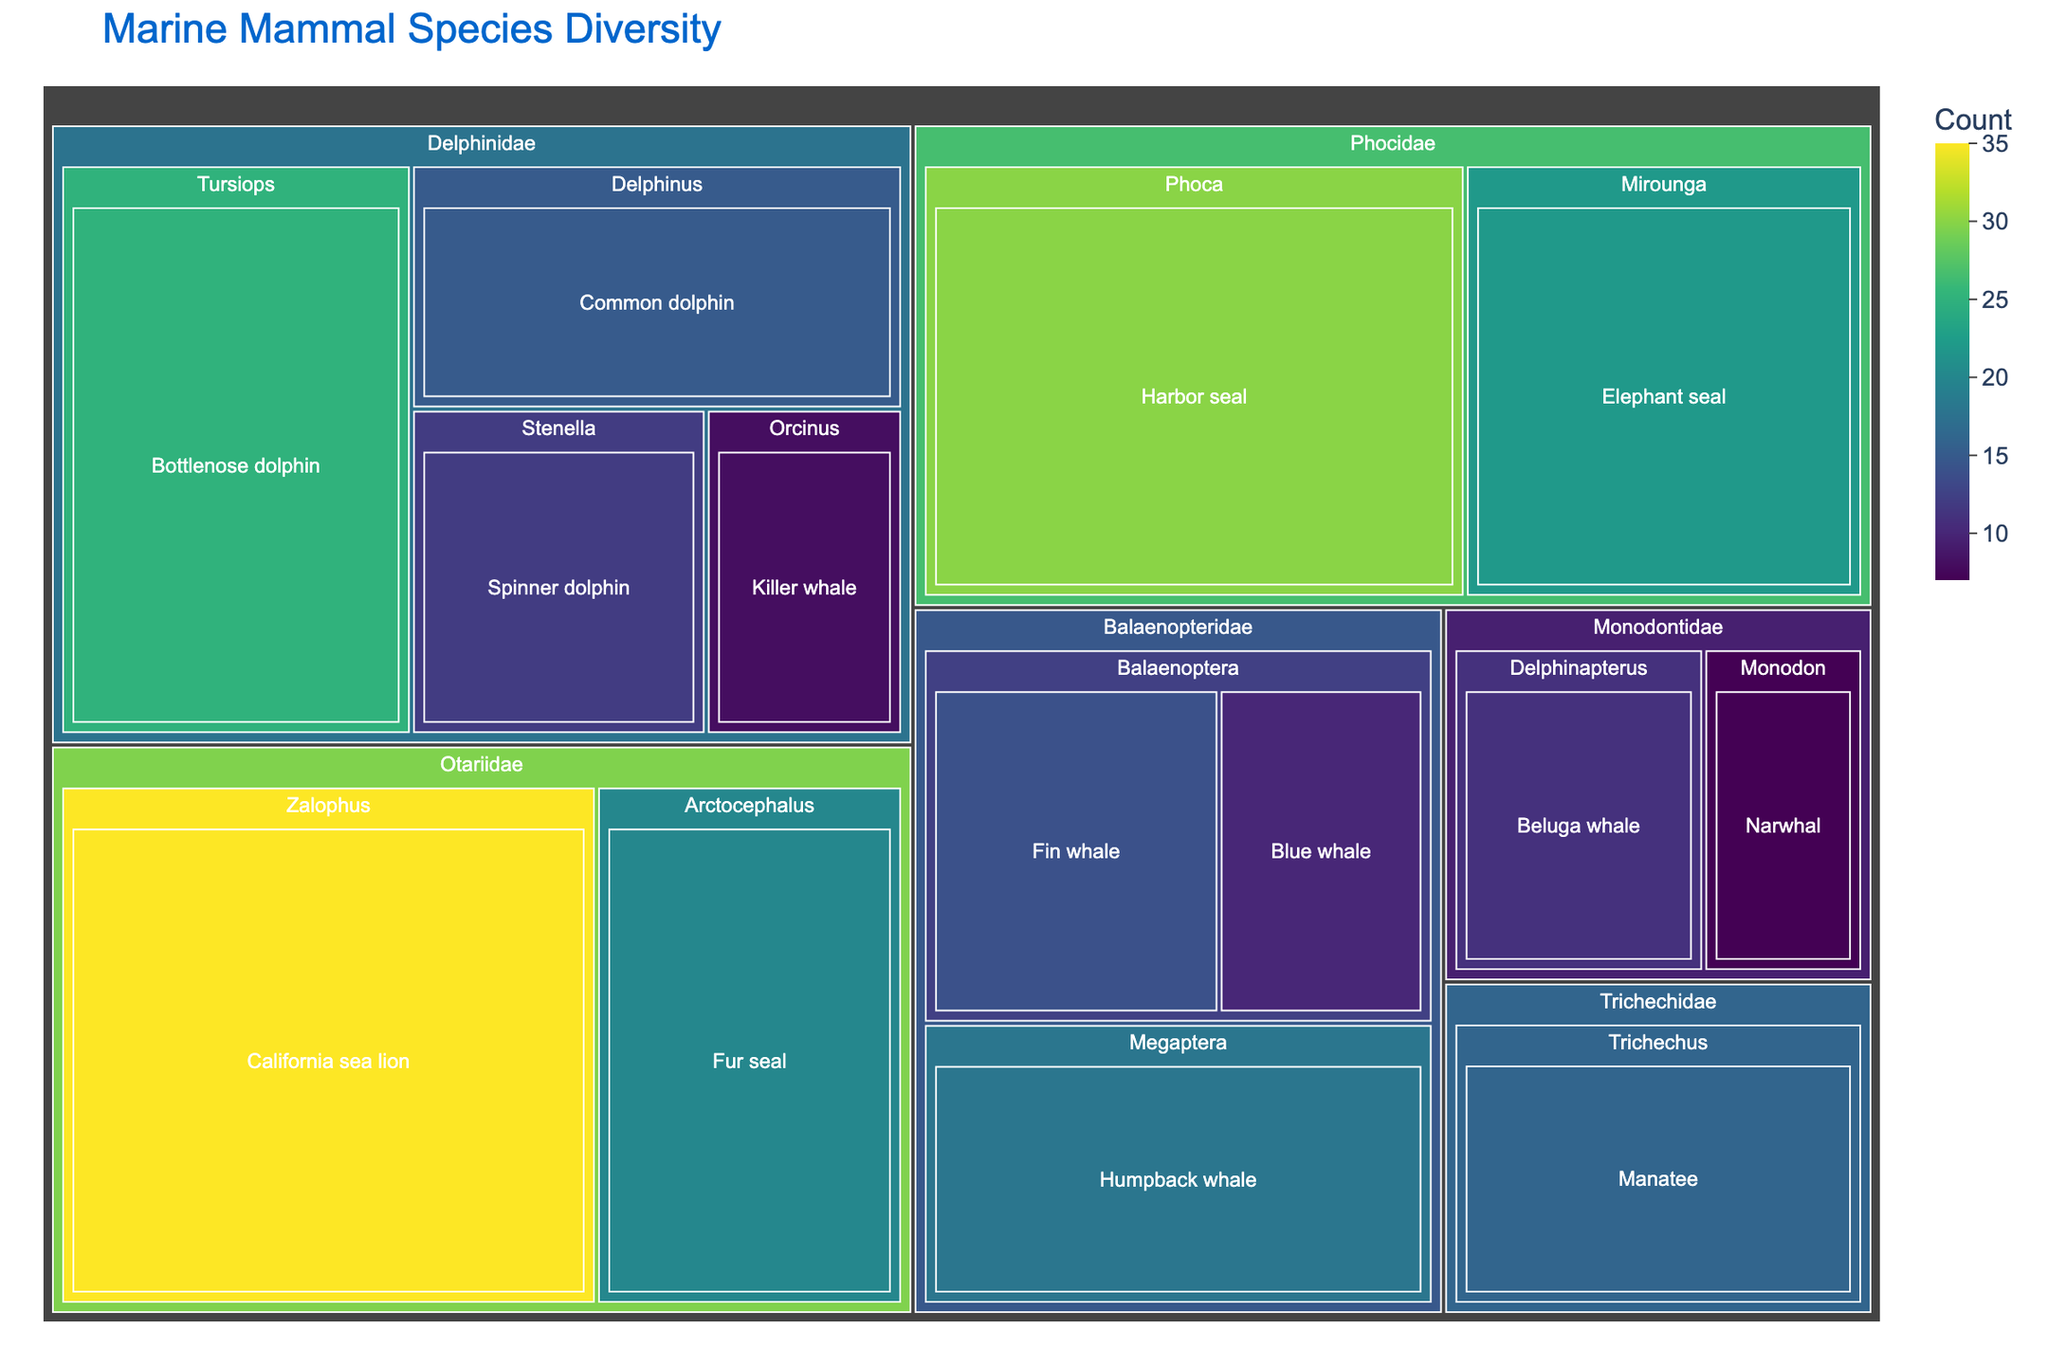How many different marine mammal species are displayed in the figure? Count each unique species label in the treemap.
Answer: 14 Which family has the highest species count? Examine the treemap to identify which family has the largest value.
Answer: Otariidae Compare the number of species in the genus "Tursiops" to the genus "Zalophus". Which genus has more species? Tursiops has 25 species and Zalophus has 35 species.
Answer: Zalophus What is the total species count for the family "Delphinidae"? Sum the species counts for all genera within the family Delphinidae: 25 (Tursiops) + 15 (Delphinus) + 12 (Stenella) + 8 (Orcinus).
Answer: 60 Which marine mammal species has the lowest count in the figure? Identify the box with the smallest count.
Answer: Narwhal What is the average species count in the family "Balaenopteridae"? Sum the counts of species in Balaenopteridae and divide by the number of species: (18 + 10 + 14)/3.
Answer: 14 Which family has a larger count when comparing "Phocidae" and "Monodontidae"? Compare the sum of species counts in each family: Phocidae (30 + 22) and Monodontidae (11 + 7).
Answer: Phocidae How many genera are there in the family "Otariidae"? Count the number of unique genus labels within Otariidae: Zalophus, Arctocephalus.
Answer: 2 What is the total species count in all families combined? Sum all species counts from the treemap: 25 + 15 + 12 + 8 + 18 + 10 + 14 + 30 + 22 + 35 + 20 + 16 + 11 + 7.
Answer: 243 Which species within the family "Phocidae" has a higher count, "Harbor seal" or "Elephant seal"? Compare the species counts: Harbor seal (30) and Elephant seal (22).
Answer: Harbor seal 